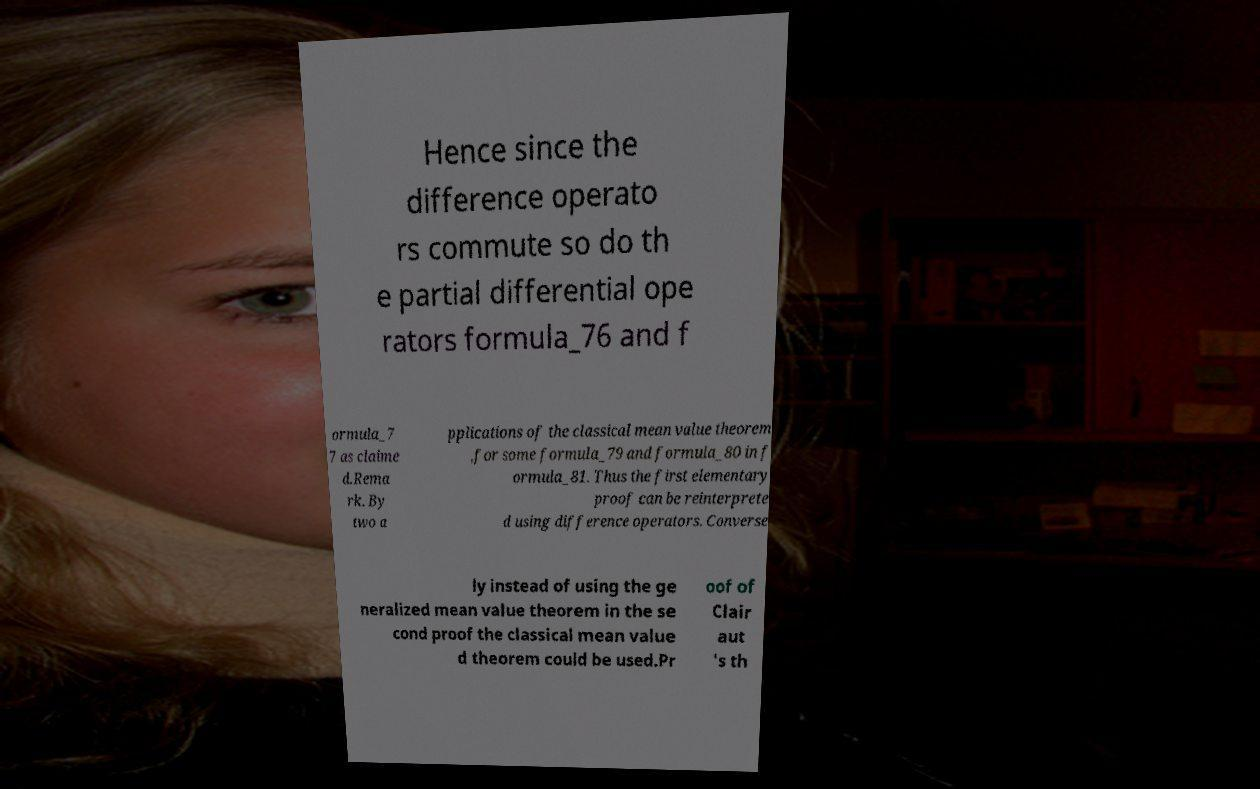Could you extract and type out the text from this image? Hence since the difference operato rs commute so do th e partial differential ope rators formula_76 and f ormula_7 7 as claime d.Rema rk. By two a pplications of the classical mean value theorem ,for some formula_79 and formula_80 in f ormula_81. Thus the first elementary proof can be reinterprete d using difference operators. Converse ly instead of using the ge neralized mean value theorem in the se cond proof the classical mean value d theorem could be used.Pr oof of Clair aut 's th 